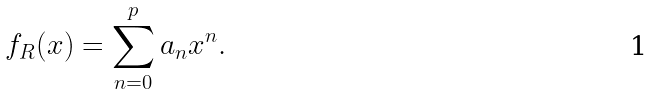<formula> <loc_0><loc_0><loc_500><loc_500>f _ { R } ( x ) = \sum _ { n = 0 } ^ { p } a _ { n } x ^ { n } .</formula> 